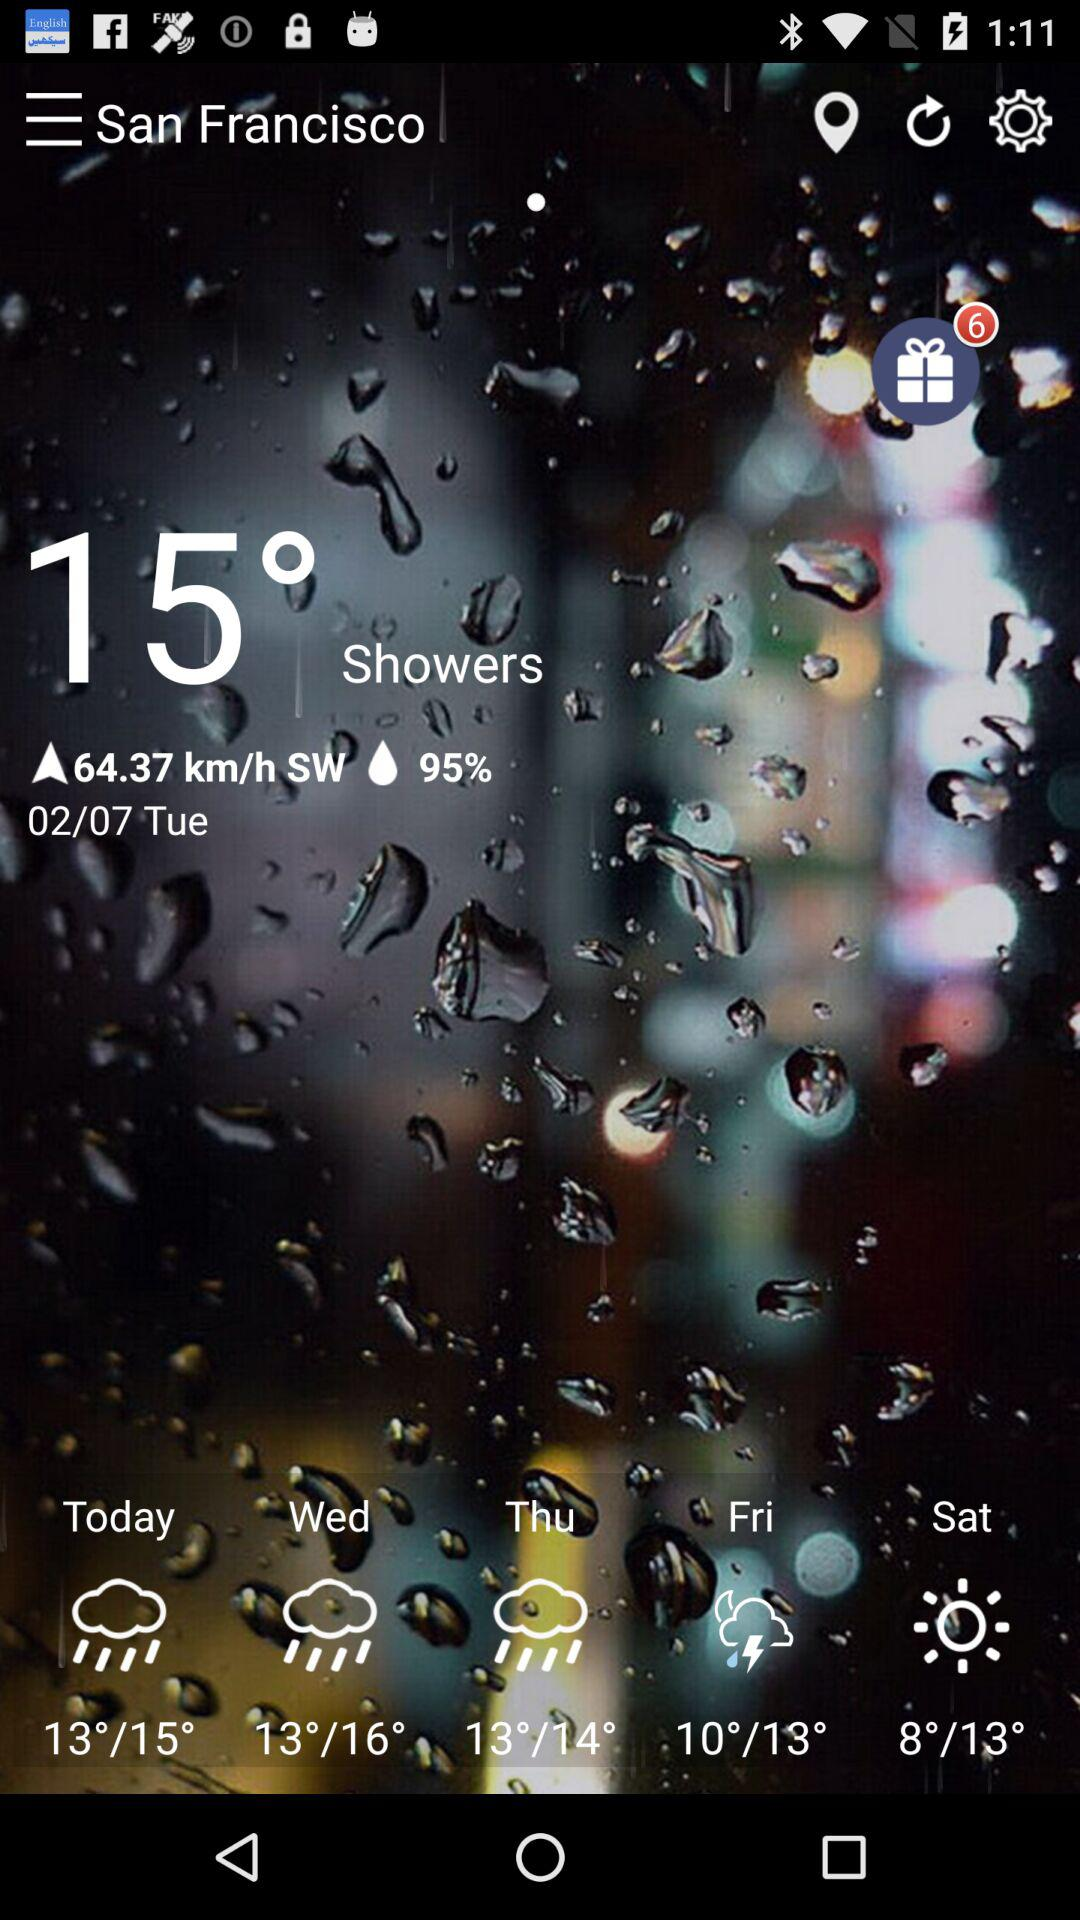What will the weather forecast be on Friday? On Friday, there will be a thunderstorm. 